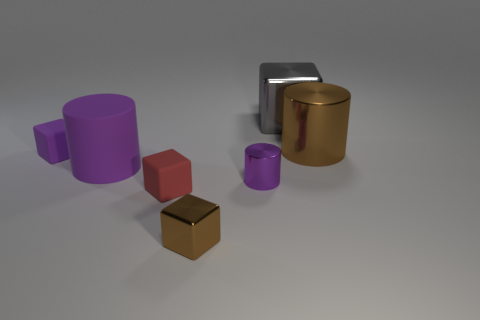Are there the same number of big gray metal cubes that are in front of the purple metallic cylinder and gray rubber cylinders? Indeed, there are an equal number of large gray metal cubes positioned in front of the purple metallic cylinder and the gray rubber cylinders, which is a single cube in each case. 